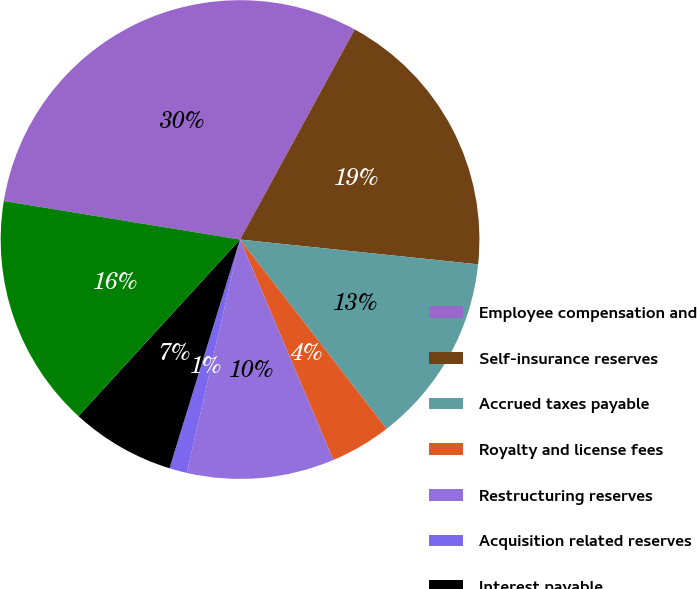Convert chart to OTSL. <chart><loc_0><loc_0><loc_500><loc_500><pie_chart><fcel>Employee compensation and<fcel>Self-insurance reserves<fcel>Accrued taxes payable<fcel>Royalty and license fees<fcel>Restructuring reserves<fcel>Acquisition related reserves<fcel>Interest payable<fcel>Other<nl><fcel>30.38%<fcel>18.7%<fcel>12.86%<fcel>4.11%<fcel>9.95%<fcel>1.19%<fcel>7.03%<fcel>15.78%<nl></chart> 